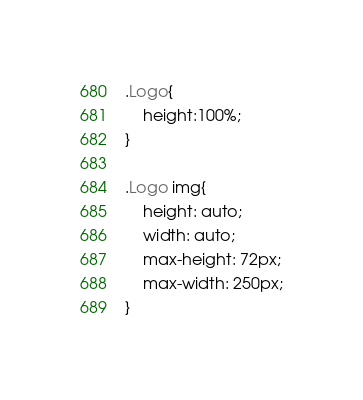<code> <loc_0><loc_0><loc_500><loc_500><_CSS_>.Logo{
    height:100%;
}

.Logo img{
    height: auto;
    width: auto;
    max-height: 72px;
    max-width: 250px;
}</code> 